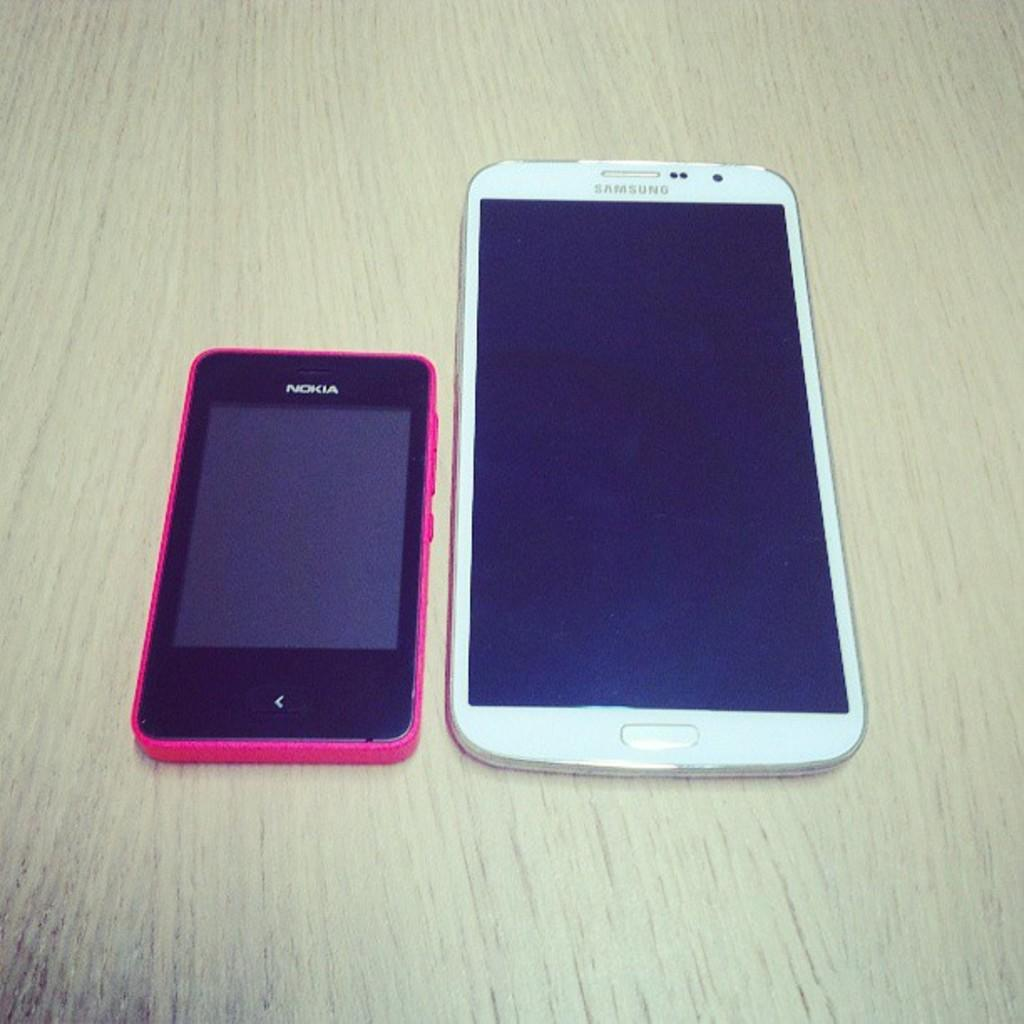<image>
Write a terse but informative summary of the picture. A Nokia phone sits on a table near a Samsung phone. 